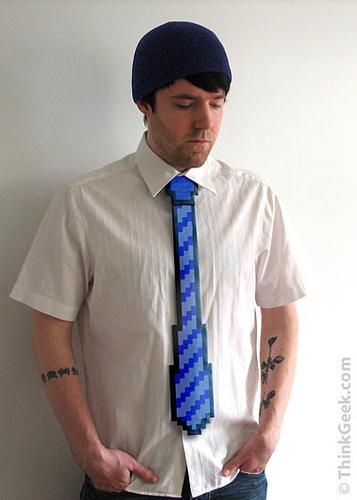Does the man's shirt have a pocket?
Keep it brief. No. Is he outdoors?
Be succinct. No. Does he think he's clever?
Write a very short answer. Yes. Is he dressed in a suit?
Concise answer only. No. Is the man wearing glasses?
Short answer required. No. Is he wearing a suit?
Be succinct. No. Where is the man's hand at?
Short answer required. Pocket. What is on the man's right arm?
Quick response, please. Tattoo. Does this man have glasses?
Quick response, please. No. Where is the blue tie?
Short answer required. On his neck. What color is the man's tie?
Quick response, please. Blue. 